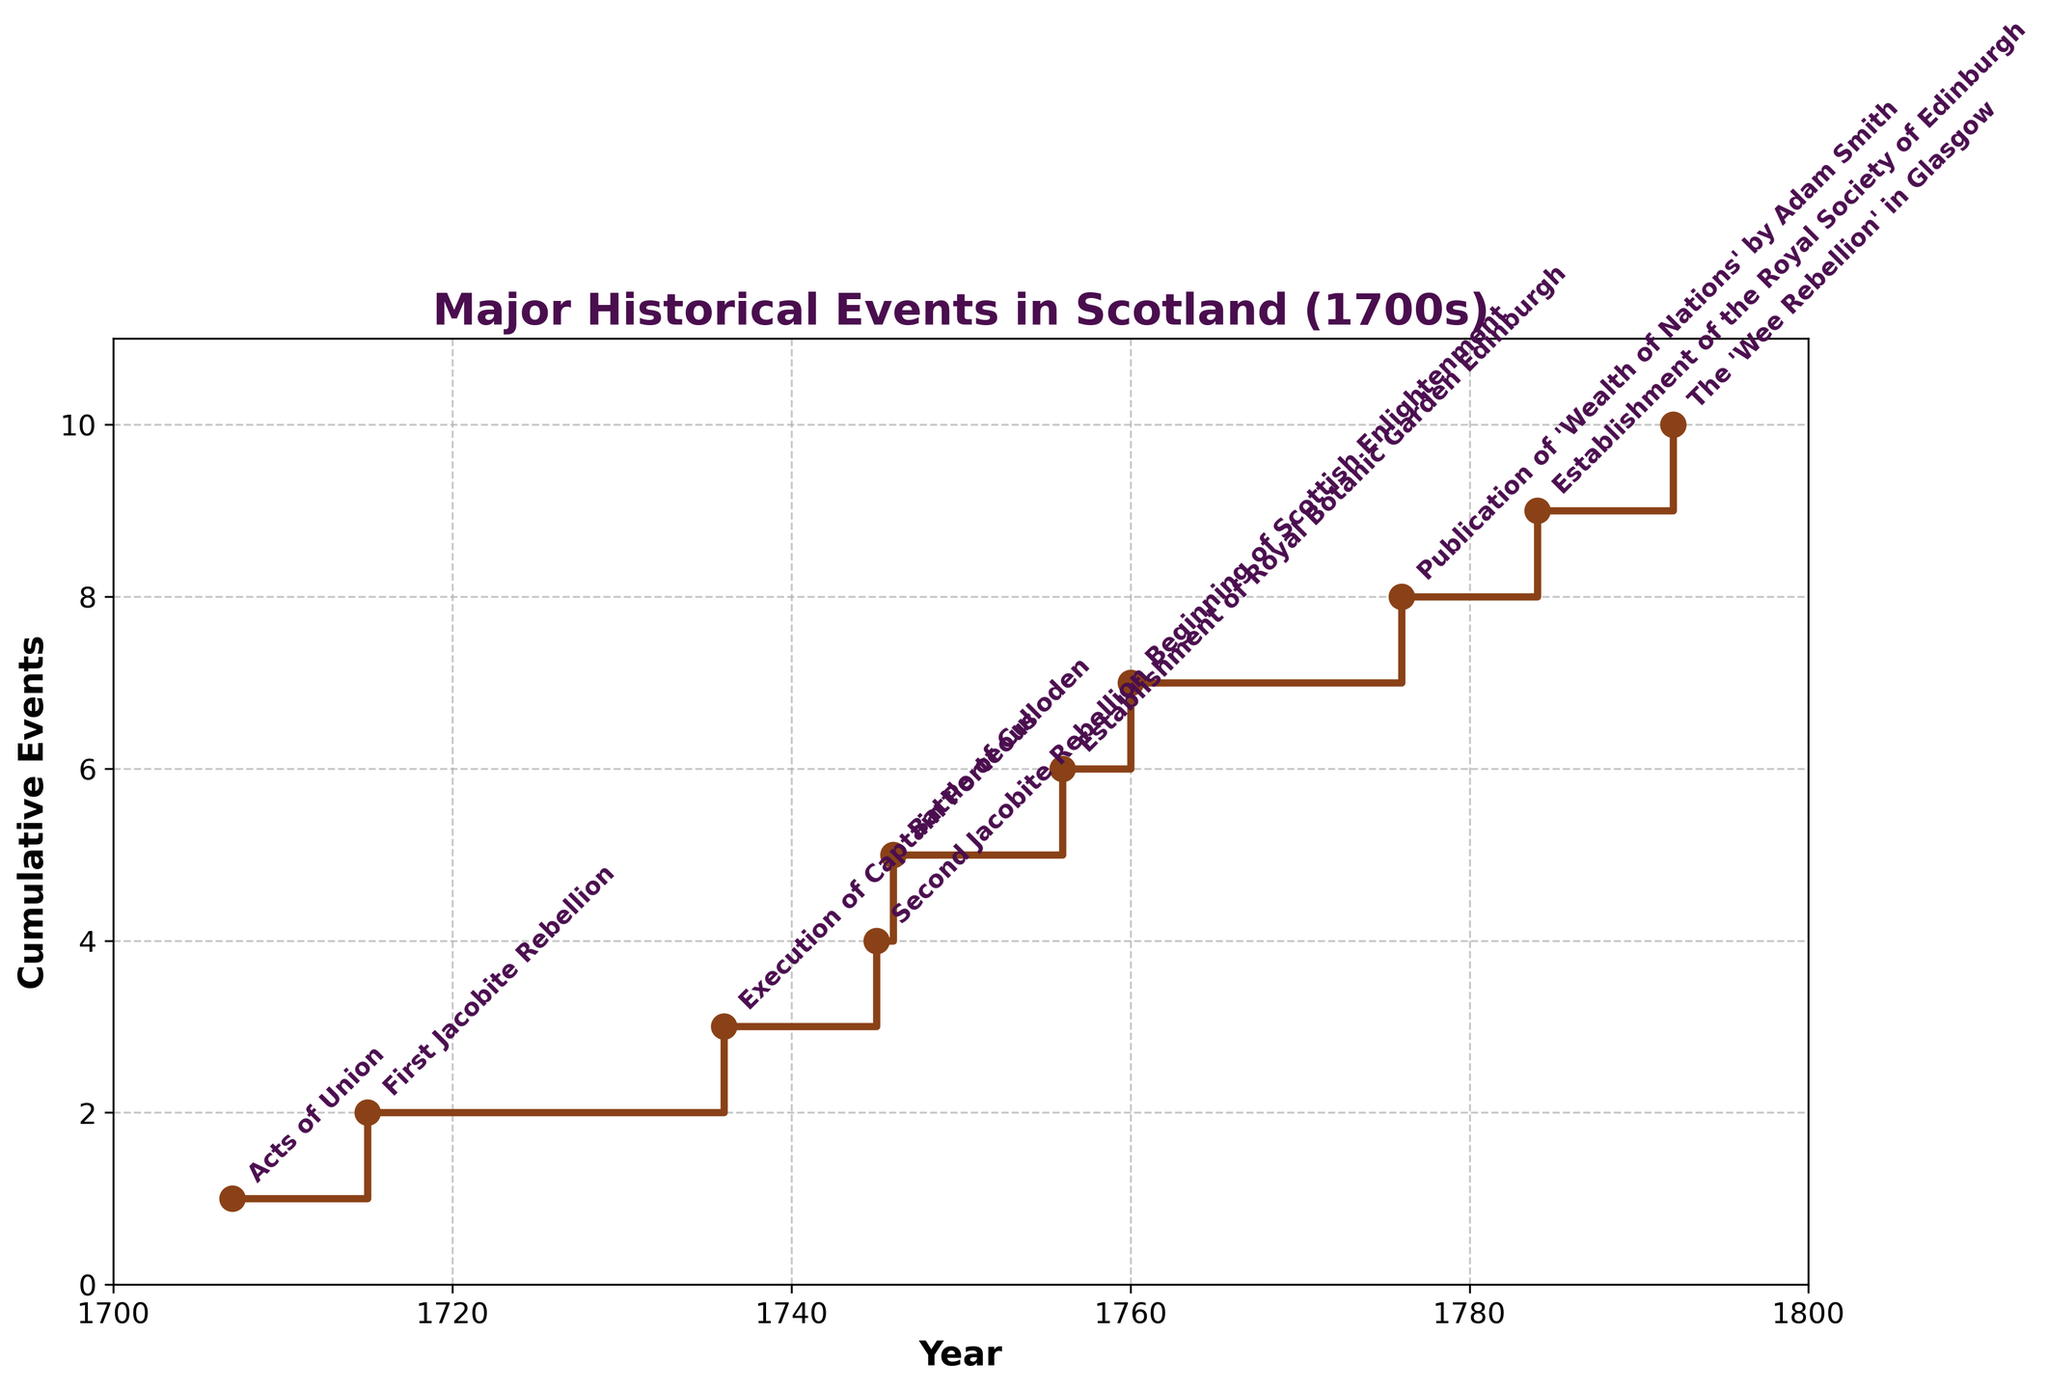What is the title of the plot? The title of the plot is shown at the top. It reads "Major Historical Events in Scotland (1700s)".
Answer: Major Historical Events in Scotland (1700s) How many cumulative events are recorded by the year 1746? The cumulative events by the year 1746 can be found on the y-axis corresponding to the year 1746 on the x-axis. The plot shows a step at 5 for the year 1746.
Answer: 5 Which year marks the beginning of the Scottish Enlightenment according to the plot? By looking at the annotations near the steps, the plot marks the year 1760 as the beginning of the Scottish Enlightenment.
Answer: 1760 What is the frequency difference in major events between the years 1715 and 1756? The frequency difference in major events between any two years can be determined by subtracting their cumulative events. In 1715, there is 1 cumulative event, and by 1756, there are 5. Thus, the difference is 5 - 1.
Answer: 4 What are the first two historical events recorded in the 1700s as per the plot? The first two historical events can be found by looking at the initial annotated steps. The plot shows "Acts of Union" in 1707 and "First Jacobite Rebellion" in 1715.
Answer: Acts of Union, First Jacobite Rebellion Which historical event caused a jump from 4 to 5 cumulative events? By tracing the steps in the plot, it can be seen that the jump from 4 to 5 cumulative events happens in 1746. The annotation shows "Battle of Culloden" next to the step.
Answer: Battle of Culloden What is the span of years covered in the plot? The span of years covered in the plot can be determined by looking at the x-axis range. It starts at 1707 and ends at 1792.
Answer: 85 years When was the Royal Society of Edinburgh established according to the plot? The annotation next to the step in the year 1784 identifies the event as the establishment of the Royal Society of Edinburgh.
Answer: 1784 